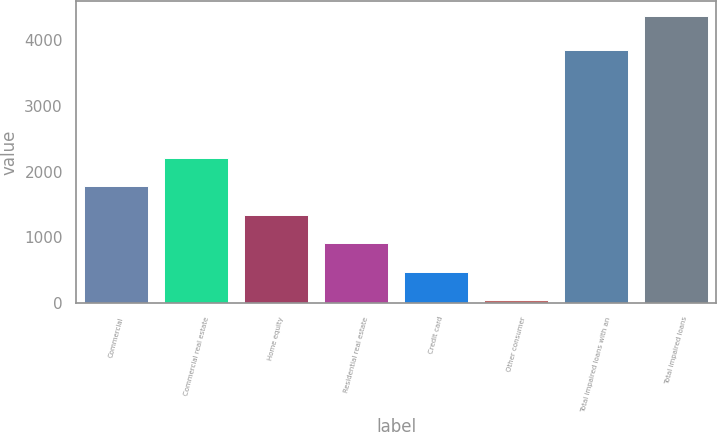<chart> <loc_0><loc_0><loc_500><loc_500><bar_chart><fcel>Commercial<fcel>Commercial real estate<fcel>Home equity<fcel>Residential real estate<fcel>Credit card<fcel>Other consumer<fcel>Total impaired loans with an<fcel>Total impaired loans<nl><fcel>1773<fcel>2206.5<fcel>1339.5<fcel>906<fcel>472.5<fcel>39<fcel>3857<fcel>4374<nl></chart> 